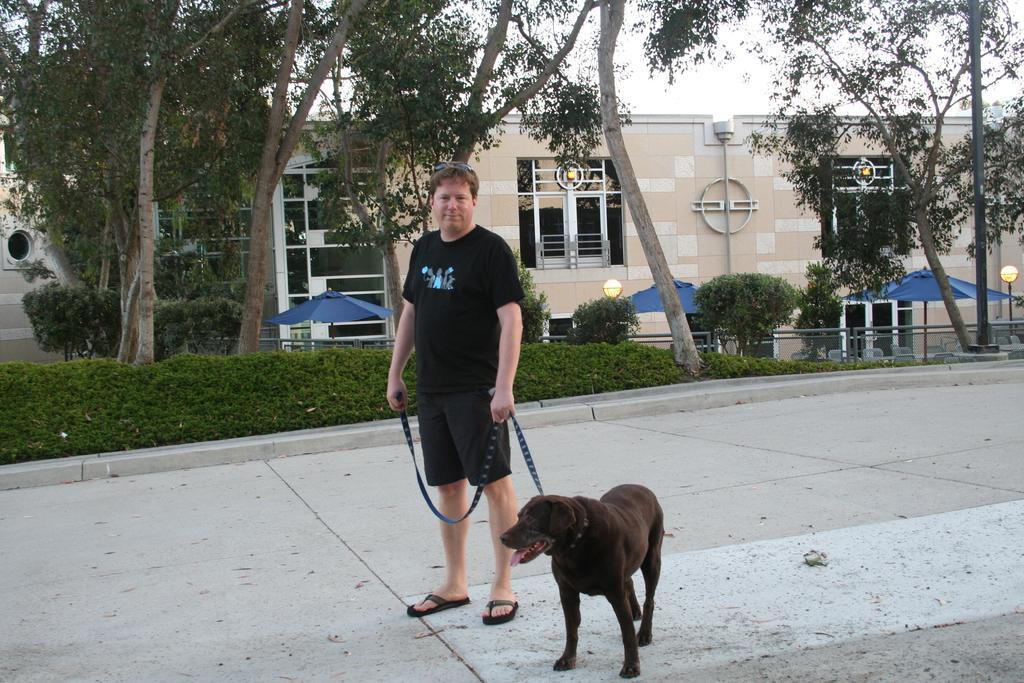How would you summarize this image in a sentence or two? In this picture we can see a man who is standing on the road. There is a dog and these are the plants. On the background there is a building and these are the trees. And there is a sky. 